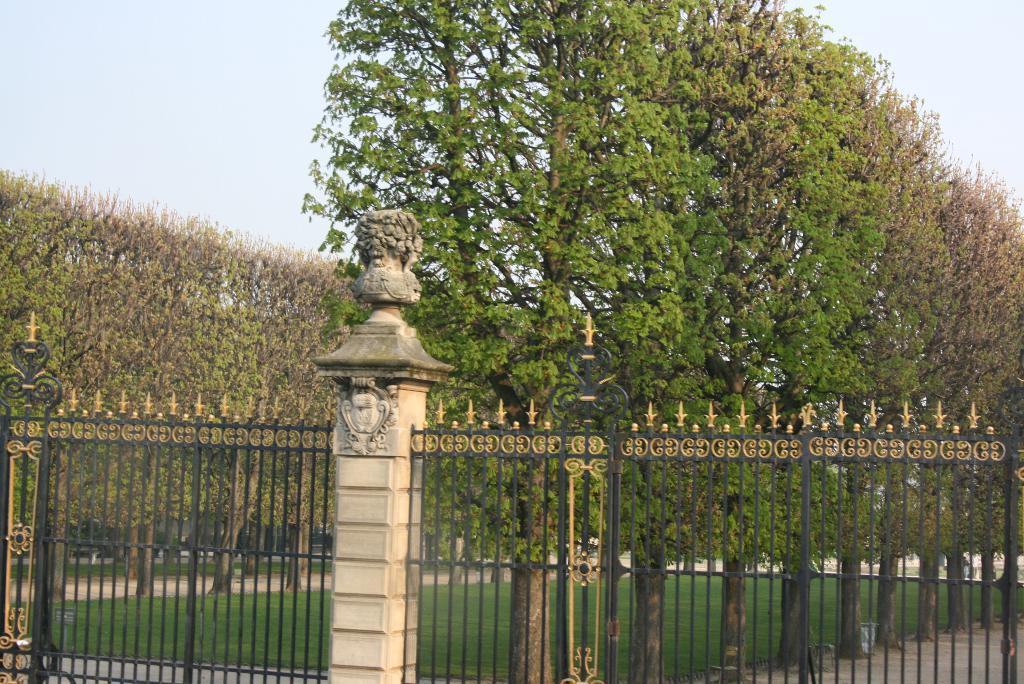In one or two sentences, can you explain what this image depicts? This is the picture of a place where we have a fencing to which there is a pillar which has some sculptors and behind there are some water and some trees and plants. 